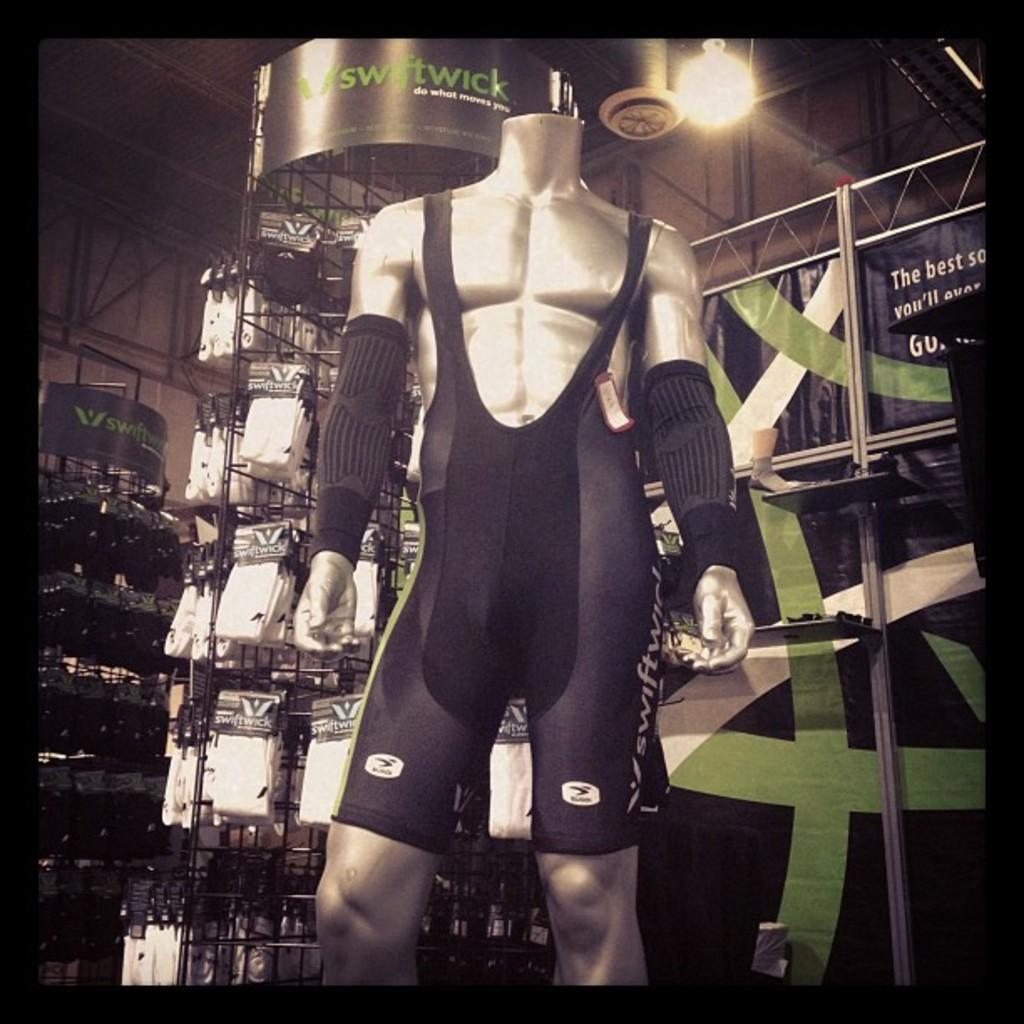How would you summarize this image in a sentence or two? In this picture we can see a mannequin, tag and at the back of this mannequin we can see posters, racks, light, rods and some objects. 